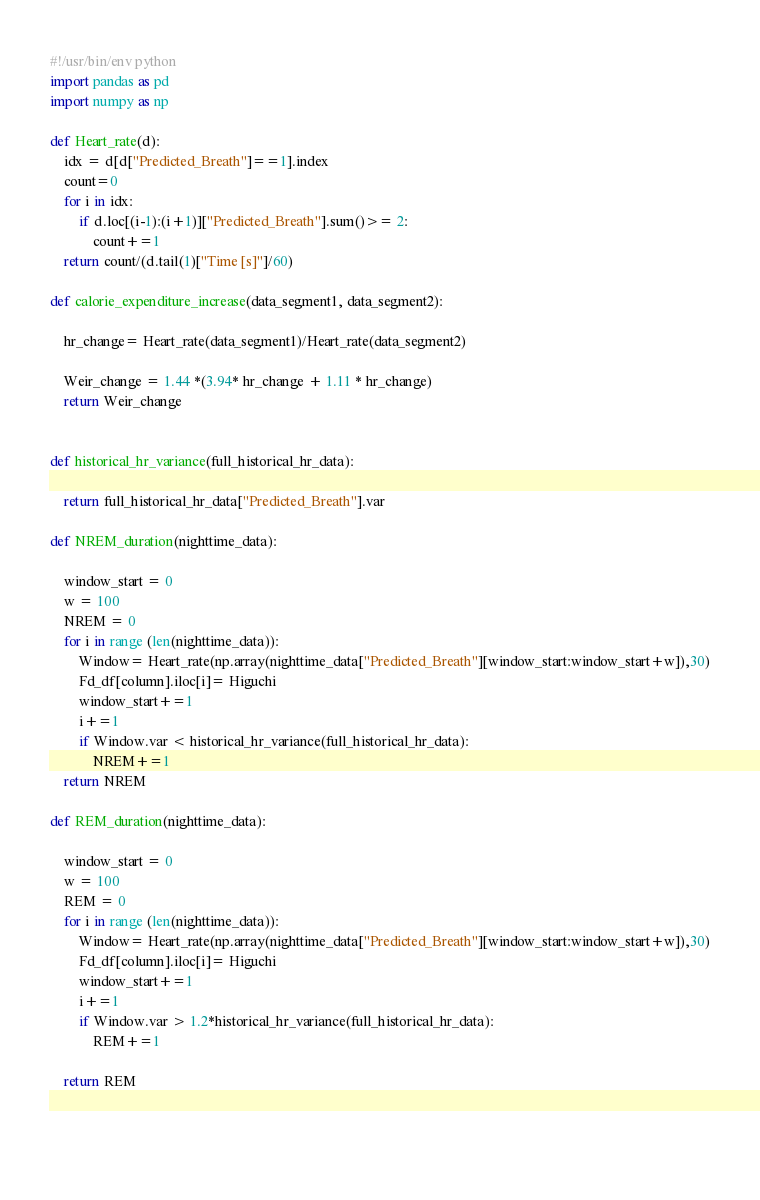<code> <loc_0><loc_0><loc_500><loc_500><_Python_>#!/usr/bin/env python
import pandas as pd
import numpy as np

def Heart_rate(d):
    idx = d[d["Predicted_Breath"]==1].index
    count=0
    for i in idx:
        if d.loc[(i-1):(i+1)]["Predicted_Breath"].sum()>= 2:
            count+=1
    return count/(d.tail(1)["Time [s]"]/60)
    
def calorie_expenditure_increase(data_segment1, data_segment2):
    
    hr_change= Heart_rate(data_segment1)/Heart_rate(data_segment2)
    
    Weir_change = 1.44 *(3.94* hr_change + 1.11 * hr_change)
    return Weir_change


def historical_hr_variance(full_historical_hr_data):
    
    return full_historical_hr_data["Predicted_Breath"].var
    
def NREM_duration(nighttime_data):
    
    window_start = 0
    w = 100
    NREM = 0
    for i in range (len(nighttime_data)):
        Window= Heart_rate(np.array(nighttime_data["Predicted_Breath"][window_start:window_start+w]),30)
        Fd_df[column].iloc[i]= Higuchi
        window_start+=1
        i+=1
        if Window.var < historical_hr_variance(full_historical_hr_data):
            NREM+=1
    return NREM
        
def REM_duration(nighttime_data):
    
    window_start = 0
    w = 100
    REM = 0
    for i in range (len(nighttime_data)):
        Window= Heart_rate(np.array(nighttime_data["Predicted_Breath"][window_start:window_start+w]),30)
        Fd_df[column].iloc[i]= Higuchi
        window_start+=1
        i+=1
        if Window.var > 1.2*historical_hr_variance(full_historical_hr_data):
            REM+=1
            
    return REM        
        
        
        </code> 